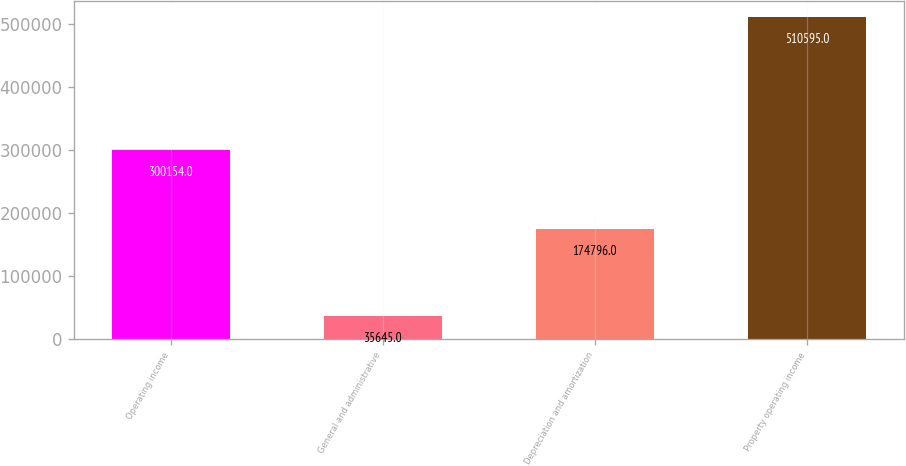Convert chart to OTSL. <chart><loc_0><loc_0><loc_500><loc_500><bar_chart><fcel>Operating income<fcel>General and administrative<fcel>Depreciation and amortization<fcel>Property operating income<nl><fcel>300154<fcel>35645<fcel>174796<fcel>510595<nl></chart> 